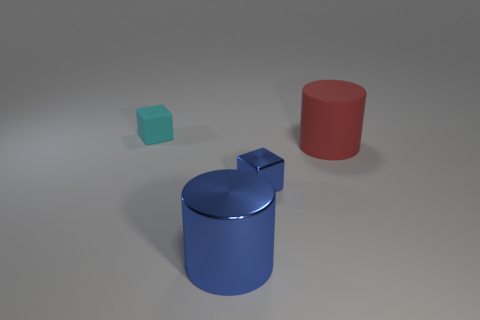Add 1 small purple rubber blocks. How many objects exist? 5 Subtract all rubber cylinders. Subtract all large red rubber cylinders. How many objects are left? 2 Add 2 blue shiny things. How many blue shiny things are left? 4 Add 2 tiny blue blocks. How many tiny blue blocks exist? 3 Subtract 0 yellow cylinders. How many objects are left? 4 